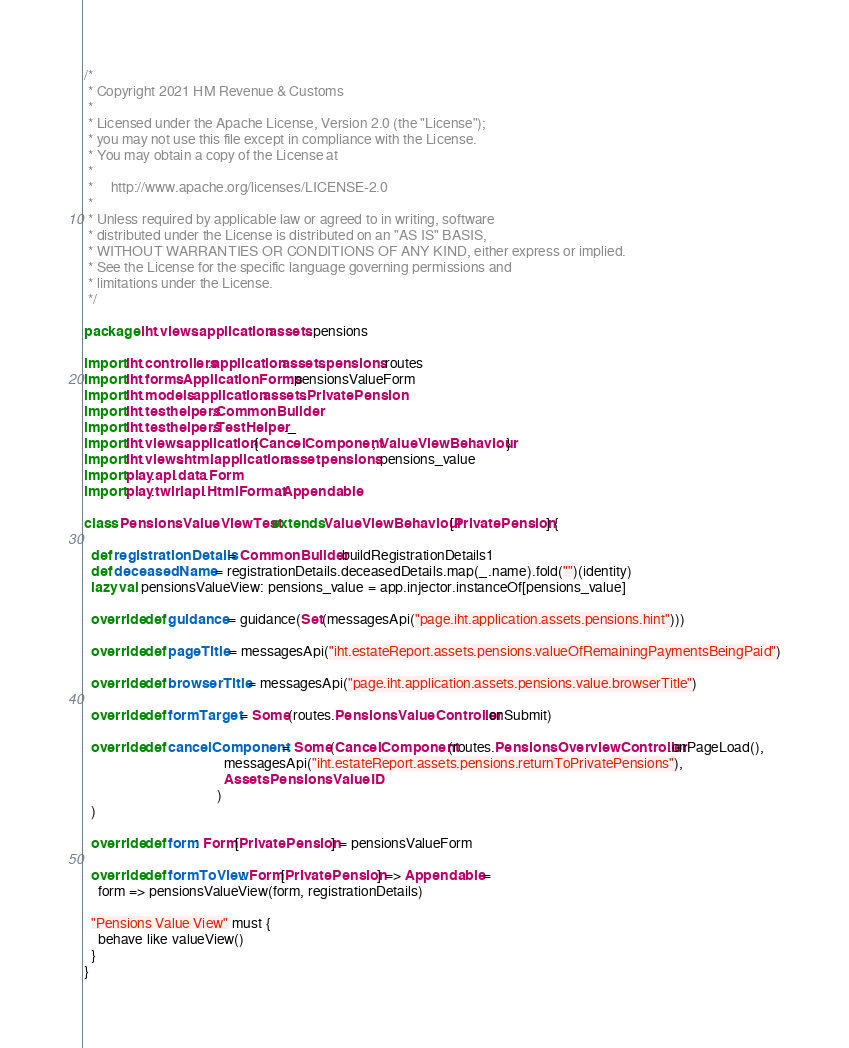<code> <loc_0><loc_0><loc_500><loc_500><_Scala_>/*
 * Copyright 2021 HM Revenue & Customs
 *
 * Licensed under the Apache License, Version 2.0 (the "License");
 * you may not use this file except in compliance with the License.
 * You may obtain a copy of the License at
 *
 *     http://www.apache.org/licenses/LICENSE-2.0
 *
 * Unless required by applicable law or agreed to in writing, software
 * distributed under the License is distributed on an "AS IS" BASIS,
 * WITHOUT WARRANTIES OR CONDITIONS OF ANY KIND, either express or implied.
 * See the License for the specific language governing permissions and
 * limitations under the License.
 */

package iht.views.application.assets.pensions

import iht.controllers.application.assets.pensions.routes
import iht.forms.ApplicationForms.pensionsValueForm
import iht.models.application.assets.PrivatePension
import iht.testhelpers.CommonBuilder
import iht.testhelpers.TestHelper._
import iht.views.application.{CancelComponent, ValueViewBehaviour}
import iht.views.html.application.asset.pensions.pensions_value
import play.api.data.Form
import play.twirl.api.HtmlFormat.Appendable

class PensionsValueViewTest extends ValueViewBehaviour[PrivatePension] {

  def registrationDetails = CommonBuilder.buildRegistrationDetails1
  def deceasedName = registrationDetails.deceasedDetails.map(_.name).fold("")(identity)
  lazy val pensionsValueView: pensions_value = app.injector.instanceOf[pensions_value]

  override def guidance = guidance(Set(messagesApi("page.iht.application.assets.pensions.hint")))

  override def pageTitle = messagesApi("iht.estateReport.assets.pensions.valueOfRemainingPaymentsBeingPaid")

  override def browserTitle = messagesApi("page.iht.application.assets.pensions.value.browserTitle")

  override def formTarget = Some(routes.PensionsValueController.onSubmit)

  override def cancelComponent = Some(CancelComponent(routes.PensionsOverviewController.onPageLoad(),
                                        messagesApi("iht.estateReport.assets.pensions.returnToPrivatePensions"),
                                        AssetsPensionsValueID
                                      )
  )

  override def form: Form[PrivatePension] = pensionsValueForm

  override def formToView: Form[PrivatePension] => Appendable =
    form => pensionsValueView(form, registrationDetails)

  "Pensions Value View" must {
    behave like valueView()
  }
}
</code> 